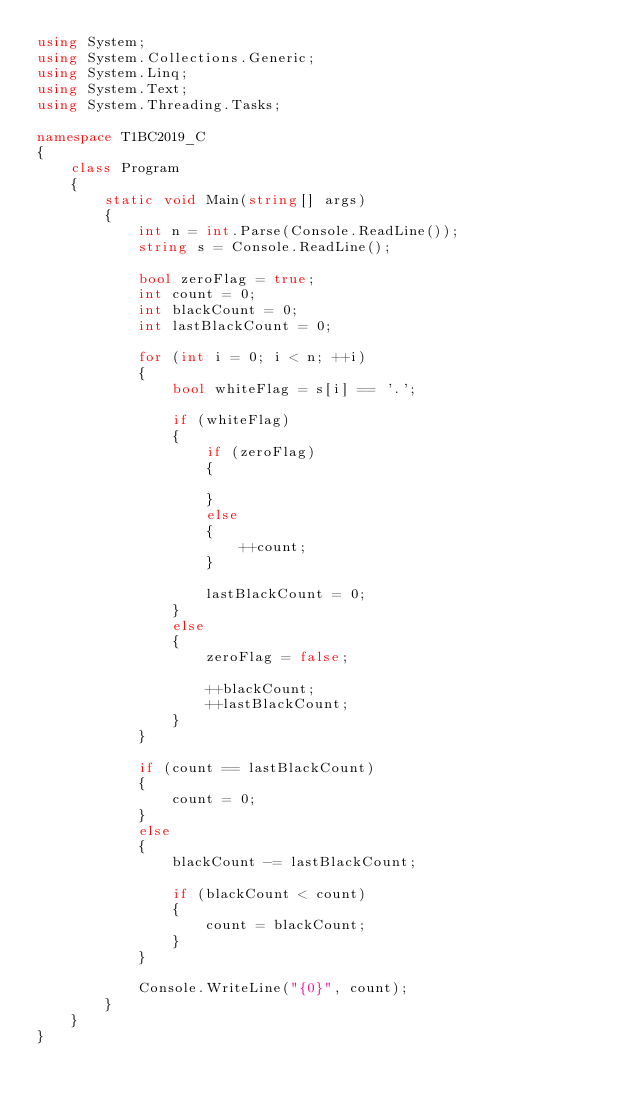<code> <loc_0><loc_0><loc_500><loc_500><_C#_>using System;
using System.Collections.Generic;
using System.Linq;
using System.Text;
using System.Threading.Tasks;

namespace T1BC2019_C
{
    class Program
    {
        static void Main(string[] args)
        {
            int n = int.Parse(Console.ReadLine());
            string s = Console.ReadLine();

            bool zeroFlag = true;
            int count = 0;
            int blackCount = 0;
            int lastBlackCount = 0;

            for (int i = 0; i < n; ++i)
            {
                bool whiteFlag = s[i] == '.';

                if (whiteFlag)
                {
                    if (zeroFlag)
                    {

                    }
                    else
                    {
                        ++count;
                    }

                    lastBlackCount = 0;
                }
                else
                {
                    zeroFlag = false;

                    ++blackCount;
                    ++lastBlackCount;
                }
            }

            if (count == lastBlackCount)
            {
                count = 0;
            }
            else
            {
                blackCount -= lastBlackCount;

                if (blackCount < count)
                {
                    count = blackCount;
                }
            }   

            Console.WriteLine("{0}", count);
        }
    }
}
</code> 